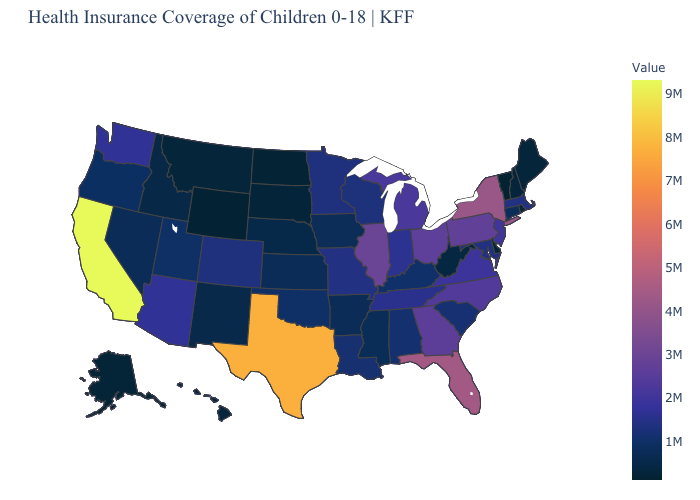Among the states that border West Virginia , which have the lowest value?
Quick response, please. Kentucky. Is the legend a continuous bar?
Concise answer only. Yes. Among the states that border Kentucky , does Ohio have the highest value?
Keep it brief. No. Among the states that border West Virginia , which have the lowest value?
Concise answer only. Kentucky. Which states have the lowest value in the West?
Quick response, please. Wyoming. Among the states that border Utah , does Idaho have the lowest value?
Keep it brief. No. Among the states that border Wyoming , does Nebraska have the highest value?
Concise answer only. No. 